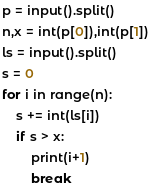<code> <loc_0><loc_0><loc_500><loc_500><_Python_>p = input().split()
n,x = int(p[0]),int(p[1])
ls = input().split()
s = 0
for i in range(n):
    s += int(ls[i])
    if s > x:
        print(i+1)
        break</code> 